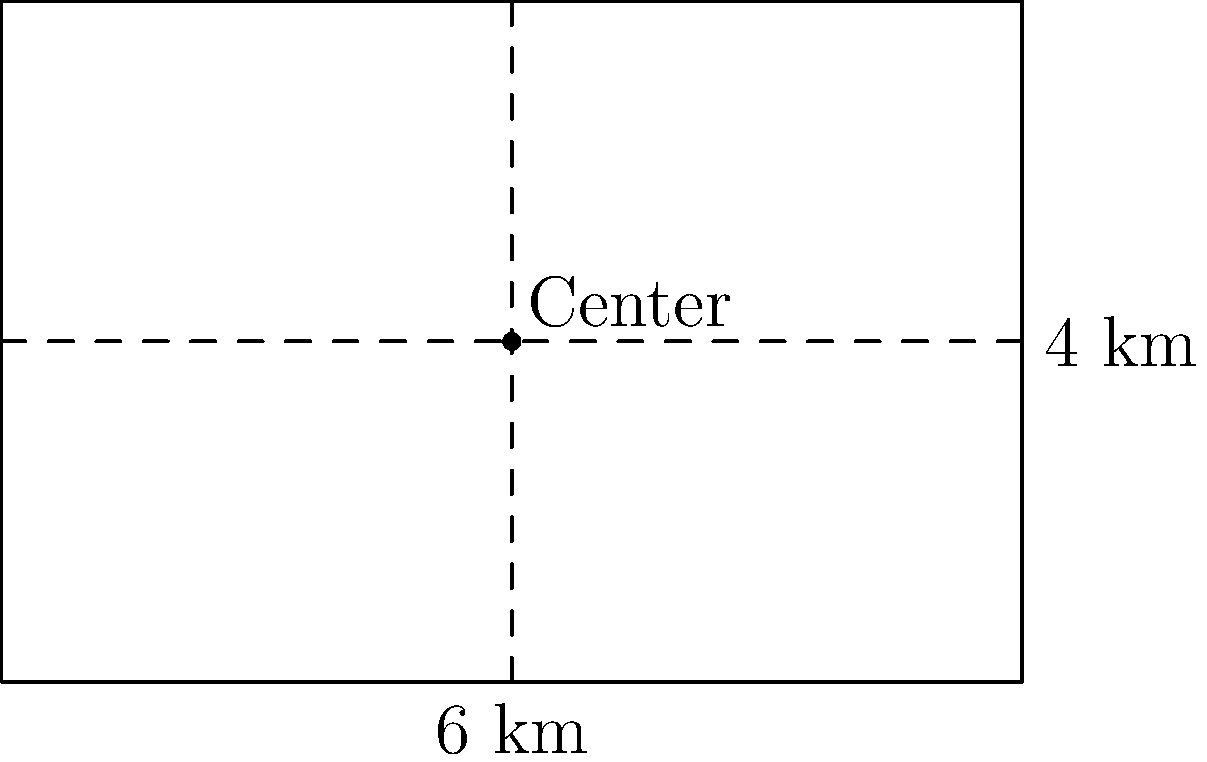You're tasked with designing a new rectangular road around a village with a fixed perimeter of 20 km. What should be the dimensions of the road to maximize the area it encloses, ensuring the most efficient use of resources and providing the largest possible space for future development? To find the most efficient rectangular shape for the road, we need to maximize the area while keeping the perimeter constant. Let's approach this step-by-step:

1) Let the width of the rectangle be $w$ and the length be $l$.

2) Given the perimeter is 20 km, we can write:
   $2w + 2l = 20$
   $w + l = 10$

3) Express $l$ in terms of $w$:
   $l = 10 - w$

4) The area $A$ of the rectangle is given by:
   $A = w * l = w(10-w) = 10w - w^2$

5) To find the maximum area, we need to find where the derivative of $A$ with respect to $w$ is zero:
   $\frac{dA}{dw} = 10 - 2w$

6) Set this equal to zero:
   $10 - 2w = 0$
   $2w = 10$
   $w = 5$

7) Since $w + l = 10$, if $w = 5$, then $l = 5$ as well.

8) To confirm this is a maximum, we can check the second derivative:
   $\frac{d^2A}{dw^2} = -2$, which is negative, confirming a maximum.

Therefore, the most efficient shape for the road is a square with sides of 5 km each.
Answer: 5 km x 5 km square 